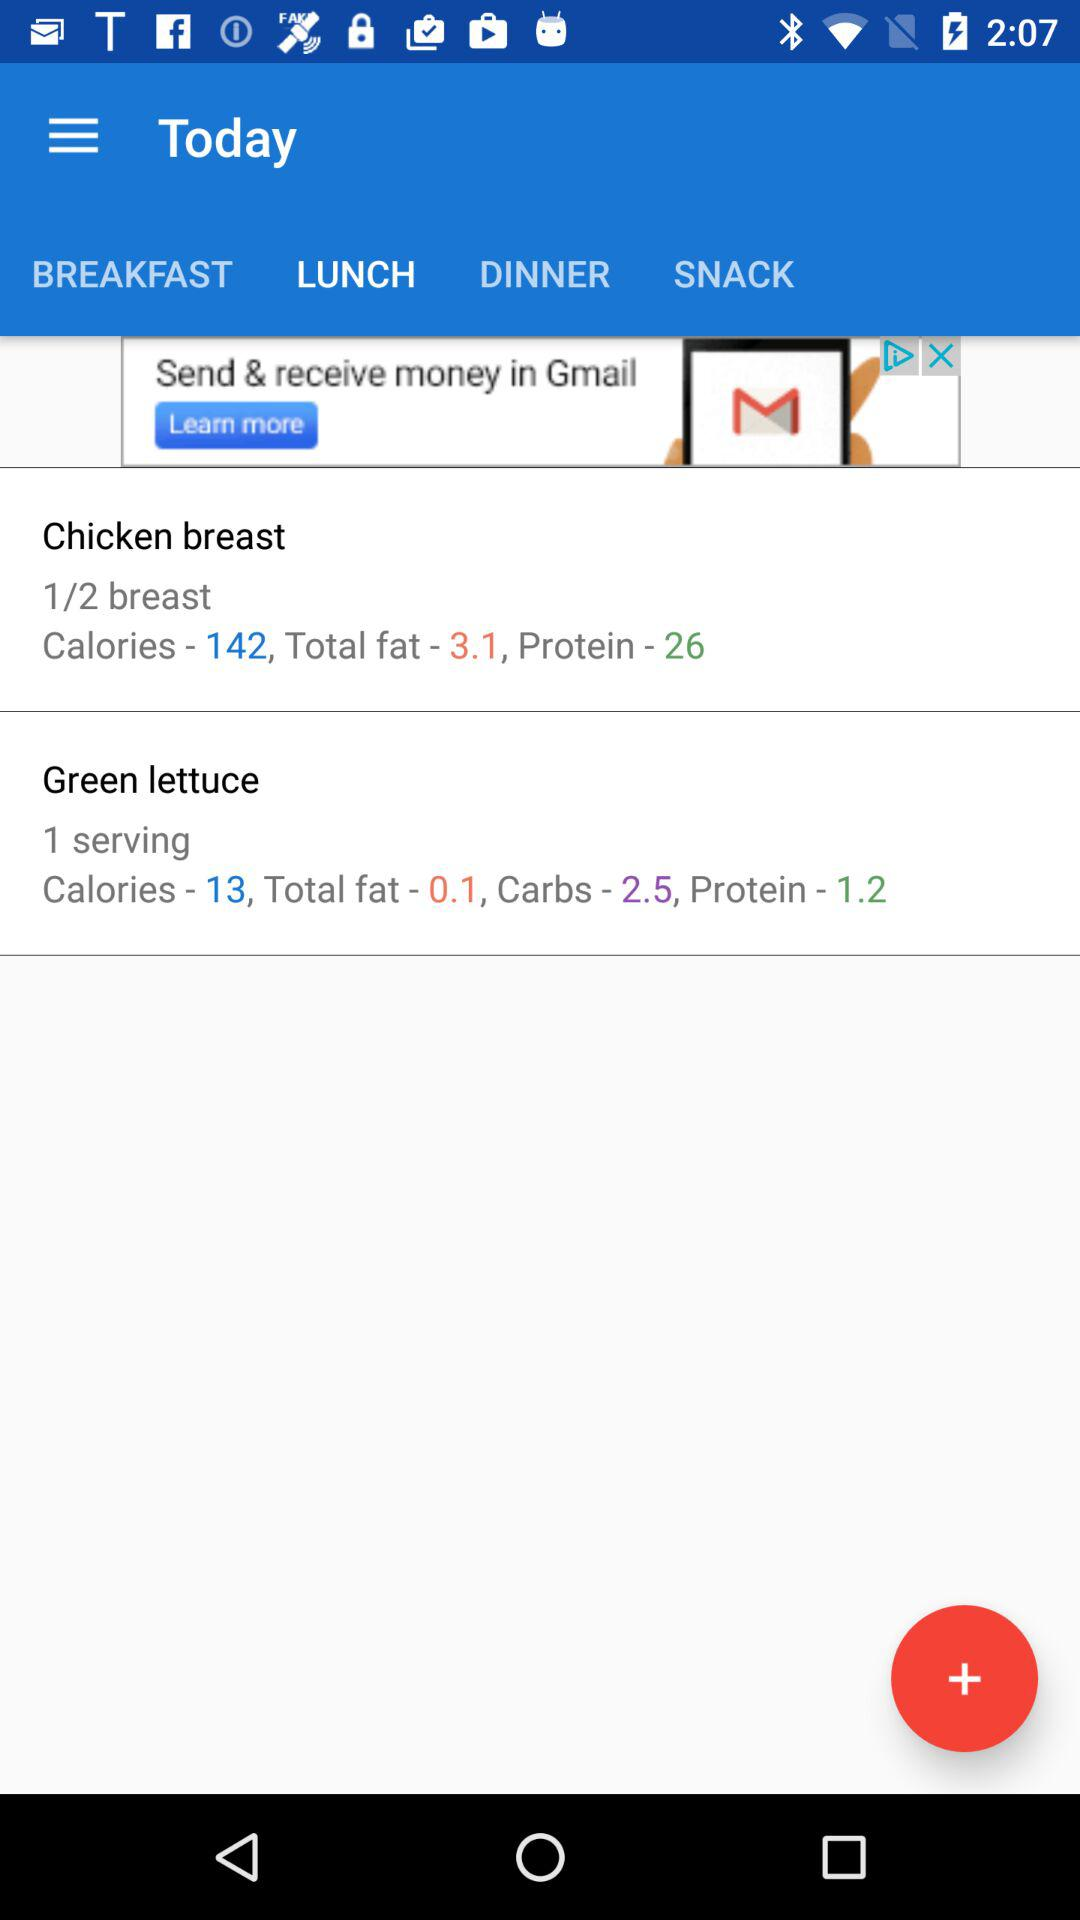How many grams of protein are in the chicken breast and green lettuce?
Answer the question using a single word or phrase. 27.2 